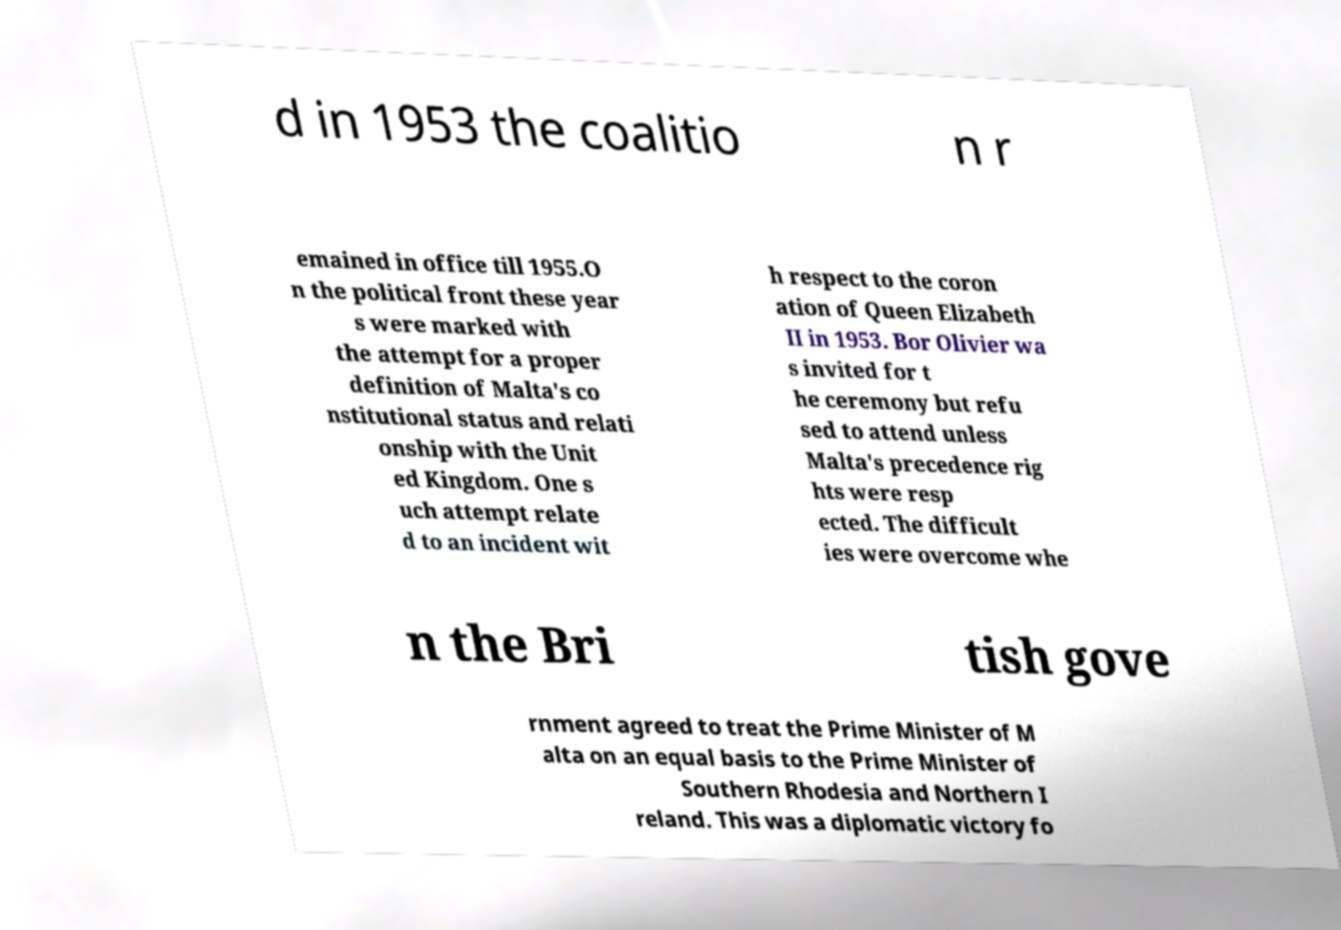Please identify and transcribe the text found in this image. d in 1953 the coalitio n r emained in office till 1955.O n the political front these year s were marked with the attempt for a proper definition of Malta's co nstitutional status and relati onship with the Unit ed Kingdom. One s uch attempt relate d to an incident wit h respect to the coron ation of Queen Elizabeth II in 1953. Bor Olivier wa s invited for t he ceremony but refu sed to attend unless Malta's precedence rig hts were resp ected. The difficult ies were overcome whe n the Bri tish gove rnment agreed to treat the Prime Minister of M alta on an equal basis to the Prime Minister of Southern Rhodesia and Northern I reland. This was a diplomatic victory fo 